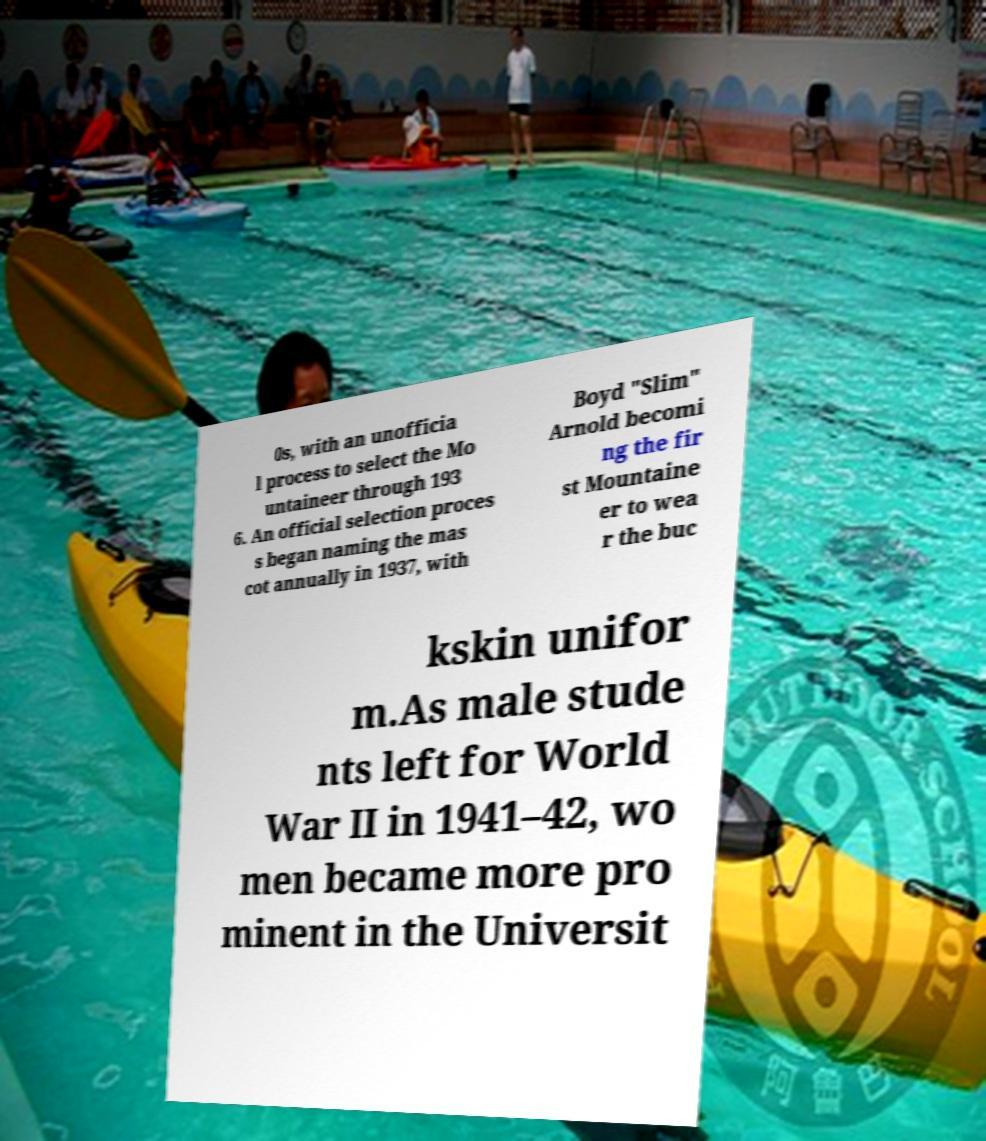Could you extract and type out the text from this image? 0s, with an unofficia l process to select the Mo untaineer through 193 6. An official selection proces s began naming the mas cot annually in 1937, with Boyd "Slim" Arnold becomi ng the fir st Mountaine er to wea r the buc kskin unifor m.As male stude nts left for World War II in 1941–42, wo men became more pro minent in the Universit 